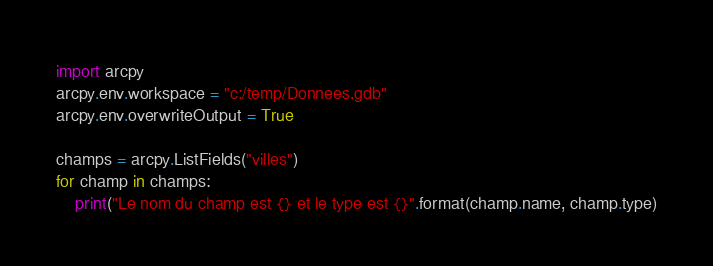Convert code to text. <code><loc_0><loc_0><loc_500><loc_500><_Python_>import arcpy
arcpy.env.workspace = "c:/temp/Donnees.gdb"
arcpy.env.overwriteOutput = True

champs = arcpy.ListFields("villes")
for champ in champs:
    print("Le nom du champ est {} et le type est {}".format(champ.name, champ.type)</code> 